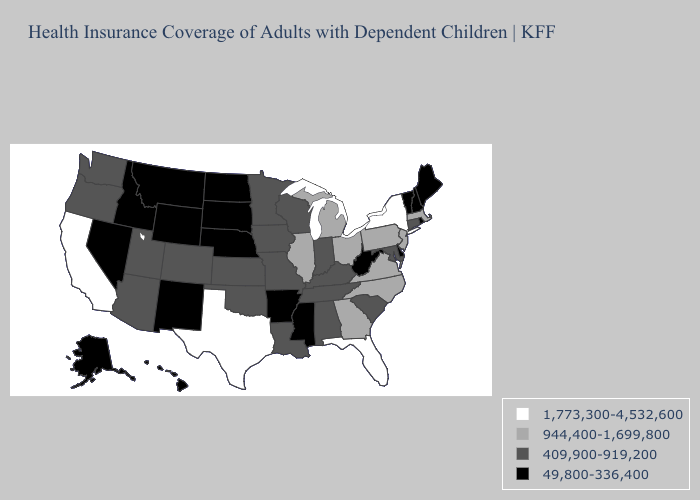Name the states that have a value in the range 944,400-1,699,800?
Keep it brief. Georgia, Illinois, Massachusetts, Michigan, New Jersey, North Carolina, Ohio, Pennsylvania, Virginia. What is the lowest value in the Northeast?
Answer briefly. 49,800-336,400. Name the states that have a value in the range 944,400-1,699,800?
Keep it brief. Georgia, Illinois, Massachusetts, Michigan, New Jersey, North Carolina, Ohio, Pennsylvania, Virginia. What is the value of Kentucky?
Quick response, please. 409,900-919,200. Does Massachusetts have the highest value in the Northeast?
Answer briefly. No. Name the states that have a value in the range 409,900-919,200?
Quick response, please. Alabama, Arizona, Colorado, Connecticut, Indiana, Iowa, Kansas, Kentucky, Louisiana, Maryland, Minnesota, Missouri, Oklahoma, Oregon, South Carolina, Tennessee, Utah, Washington, Wisconsin. Among the states that border Oklahoma , which have the lowest value?
Write a very short answer. Arkansas, New Mexico. Does Massachusetts have the lowest value in the USA?
Give a very brief answer. No. What is the value of Arizona?
Be succinct. 409,900-919,200. Name the states that have a value in the range 49,800-336,400?
Quick response, please. Alaska, Arkansas, Delaware, Hawaii, Idaho, Maine, Mississippi, Montana, Nebraska, Nevada, New Hampshire, New Mexico, North Dakota, Rhode Island, South Dakota, Vermont, West Virginia, Wyoming. Which states hav the highest value in the South?
Be succinct. Florida, Texas. What is the lowest value in the USA?
Short answer required. 49,800-336,400. What is the value of Florida?
Concise answer only. 1,773,300-4,532,600. Does California have the same value as Florida?
Keep it brief. Yes. 